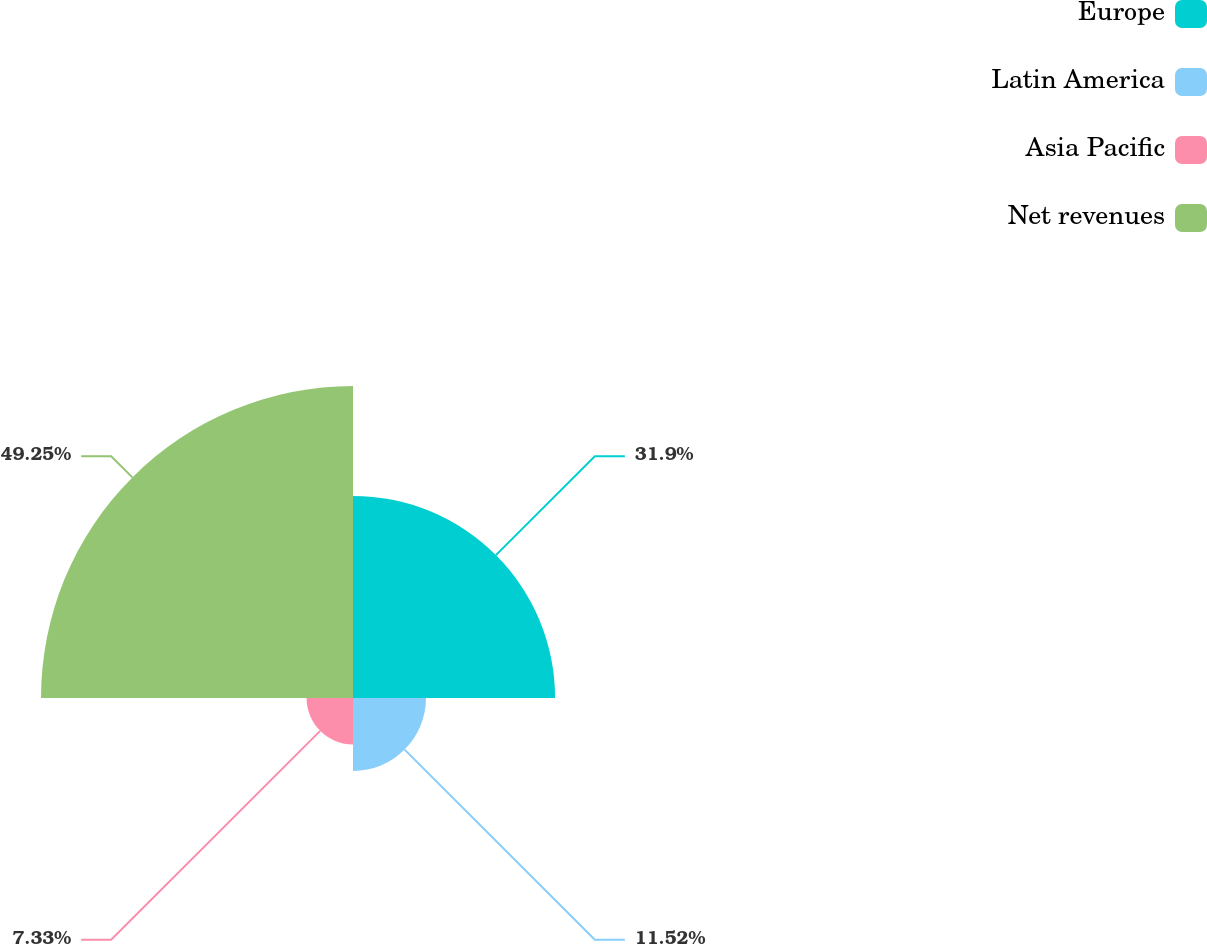Convert chart to OTSL. <chart><loc_0><loc_0><loc_500><loc_500><pie_chart><fcel>Europe<fcel>Latin America<fcel>Asia Pacific<fcel>Net revenues<nl><fcel>31.9%<fcel>11.52%<fcel>7.33%<fcel>49.25%<nl></chart> 